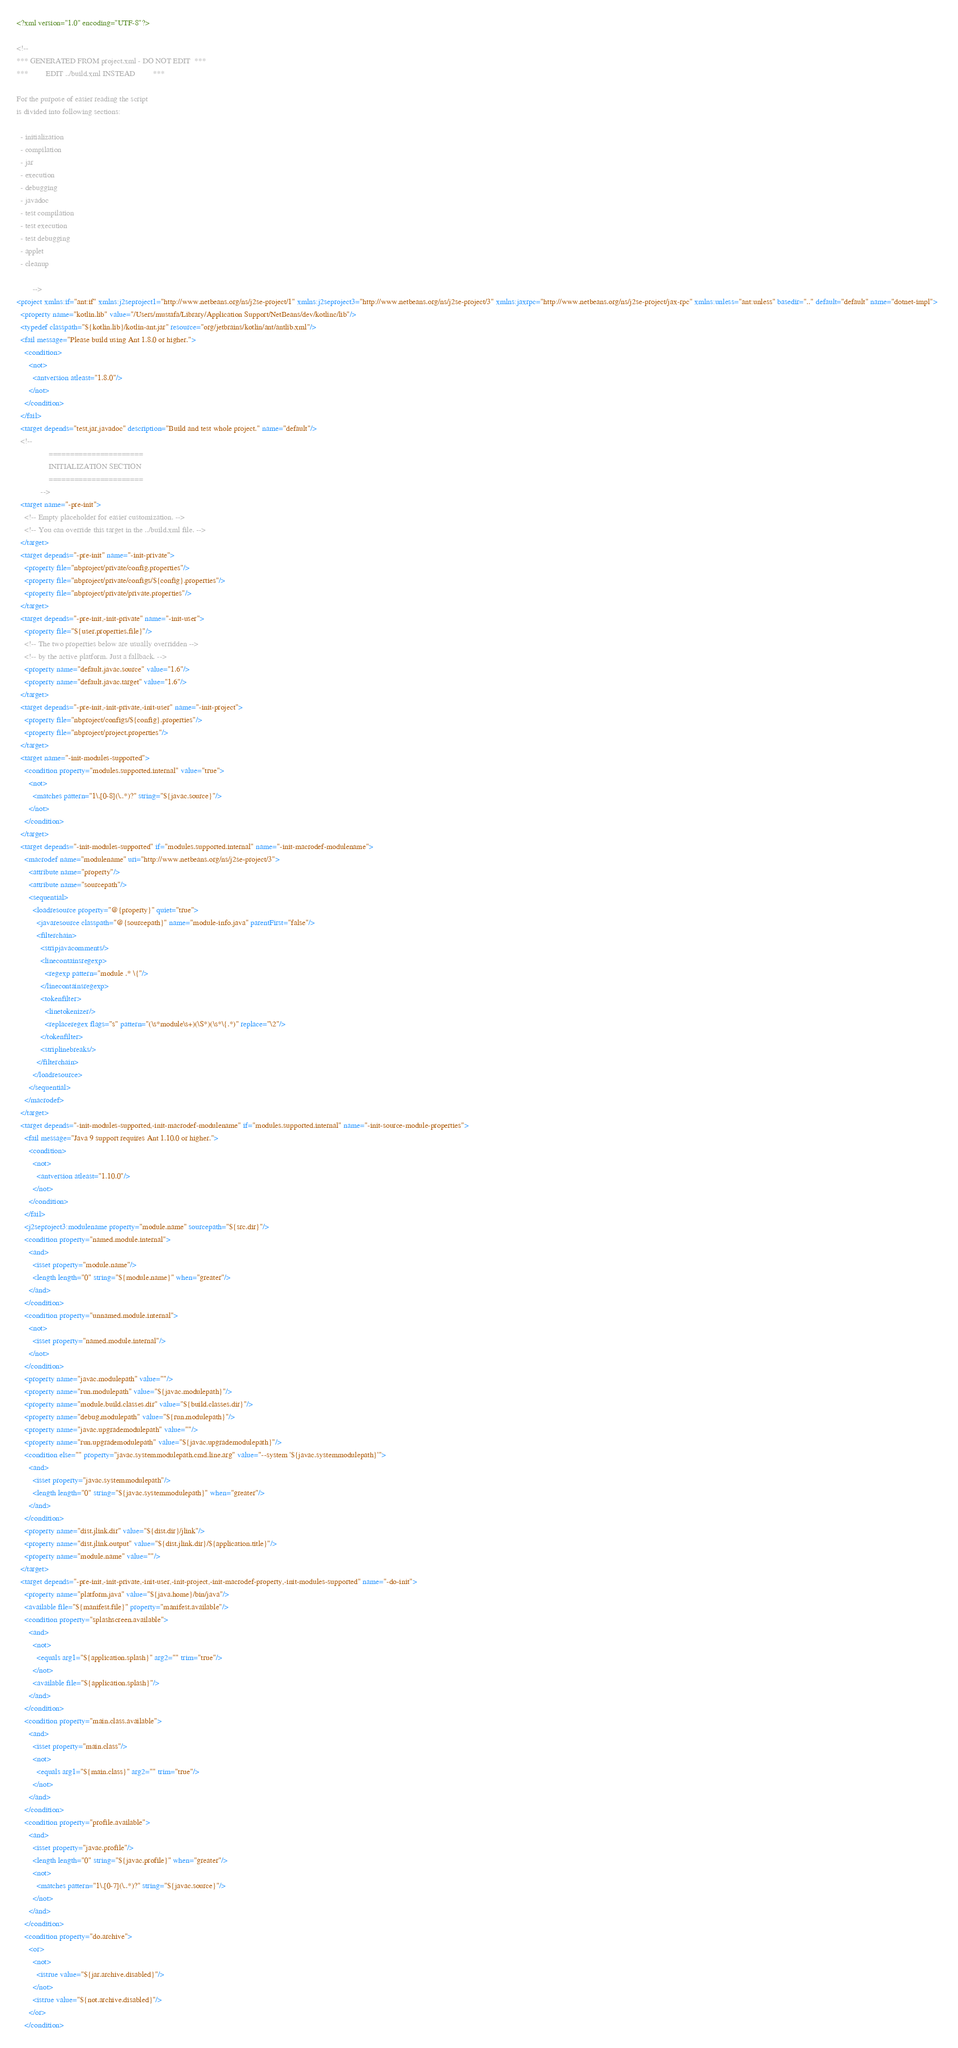Convert code to text. <code><loc_0><loc_0><loc_500><loc_500><_XML_><?xml version="1.0" encoding="UTF-8"?>

<!--
*** GENERATED FROM project.xml - DO NOT EDIT  ***
***         EDIT ../build.xml INSTEAD         ***

For the purpose of easier reading the script
is divided into following sections:

  - initialization
  - compilation
  - jar
  - execution
  - debugging
  - javadoc
  - test compilation
  - test execution
  - test debugging
  - applet
  - cleanup

        -->
<project xmlns:if="ant:if" xmlns:j2seproject1="http://www.netbeans.org/ns/j2se-project/1" xmlns:j2seproject3="http://www.netbeans.org/ns/j2se-project/3" xmlns:jaxrpc="http://www.netbeans.org/ns/j2se-project/jax-rpc" xmlns:unless="ant:unless" basedir=".." default="default" name="dotnet-impl">  
  <property name="kotlin.lib" value="/Users/mustafa/Library/Application Support/NetBeans/dev/kotlinc/lib"/>  
  <typedef classpath="${kotlin.lib}/kotlin-ant.jar" resource="org/jetbrains/kotlin/ant/antlib.xml"/>  
  <fail message="Please build using Ant 1.8.0 or higher."> 
    <condition> 
      <not> 
        <antversion atleast="1.8.0"/> 
      </not> 
    </condition> 
  </fail>  
  <target depends="test,jar,javadoc" description="Build and test whole project." name="default"/>  
  <!-- 
                ======================
                INITIALIZATION SECTION 
                ======================
            -->  
  <target name="-pre-init"> 
    <!-- Empty placeholder for easier customization. -->  
    <!-- You can override this target in the ../build.xml file. --> 
  </target>  
  <target depends="-pre-init" name="-init-private"> 
    <property file="nbproject/private/config.properties"/>  
    <property file="nbproject/private/configs/${config}.properties"/>  
    <property file="nbproject/private/private.properties"/> 
  </target>  
  <target depends="-pre-init,-init-private" name="-init-user"> 
    <property file="${user.properties.file}"/>  
    <!-- The two properties below are usually overridden -->  
    <!-- by the active platform. Just a fallback. -->  
    <property name="default.javac.source" value="1.6"/>  
    <property name="default.javac.target" value="1.6"/> 
  </target>  
  <target depends="-pre-init,-init-private,-init-user" name="-init-project"> 
    <property file="nbproject/configs/${config}.properties"/>  
    <property file="nbproject/project.properties"/> 
  </target>  
  <target name="-init-modules-supported"> 
    <condition property="modules.supported.internal" value="true"> 
      <not> 
        <matches pattern="1\.[0-8](\..*)?" string="${javac.source}"/> 
      </not> 
    </condition> 
  </target>  
  <target depends="-init-modules-supported" if="modules.supported.internal" name="-init-macrodef-modulename"> 
    <macrodef name="modulename" uri="http://www.netbeans.org/ns/j2se-project/3"> 
      <attribute name="property"/>  
      <attribute name="sourcepath"/>  
      <sequential> 
        <loadresource property="@{property}" quiet="true"> 
          <javaresource classpath="@{sourcepath}" name="module-info.java" parentFirst="false"/>  
          <filterchain> 
            <stripjavacomments/>  
            <linecontainsregexp> 
              <regexp pattern="module .* \{"/> 
            </linecontainsregexp>  
            <tokenfilter> 
              <linetokenizer/>  
              <replaceregex flags="s" pattern="(\s*module\s+)(\S*)(\s*\{.*)" replace="\2"/> 
            </tokenfilter>  
            <striplinebreaks/> 
          </filterchain> 
        </loadresource> 
      </sequential> 
    </macrodef> 
  </target>  
  <target depends="-init-modules-supported,-init-macrodef-modulename" if="modules.supported.internal" name="-init-source-module-properties"> 
    <fail message="Java 9 support requires Ant 1.10.0 or higher."> 
      <condition> 
        <not> 
          <antversion atleast="1.10.0"/> 
        </not> 
      </condition> 
    </fail>  
    <j2seproject3:modulename property="module.name" sourcepath="${src.dir}"/>  
    <condition property="named.module.internal"> 
      <and> 
        <isset property="module.name"/>  
        <length length="0" string="${module.name}" when="greater"/> 
      </and> 
    </condition>  
    <condition property="unnamed.module.internal"> 
      <not> 
        <isset property="named.module.internal"/> 
      </not> 
    </condition>  
    <property name="javac.modulepath" value=""/>  
    <property name="run.modulepath" value="${javac.modulepath}"/>  
    <property name="module.build.classes.dir" value="${build.classes.dir}"/>  
    <property name="debug.modulepath" value="${run.modulepath}"/>  
    <property name="javac.upgrademodulepath" value=""/>  
    <property name="run.upgrademodulepath" value="${javac.upgrademodulepath}"/>  
    <condition else="" property="javac.systemmodulepath.cmd.line.arg" value="--system '${javac.systemmodulepath}'"> 
      <and> 
        <isset property="javac.systemmodulepath"/>  
        <length length="0" string="${javac.systemmodulepath}" when="greater"/> 
      </and> 
    </condition>  
    <property name="dist.jlink.dir" value="${dist.dir}/jlink"/>  
    <property name="dist.jlink.output" value="${dist.jlink.dir}/${application.title}"/>  
    <property name="module.name" value=""/> 
  </target>  
  <target depends="-pre-init,-init-private,-init-user,-init-project,-init-macrodef-property,-init-modules-supported" name="-do-init"> 
    <property name="platform.java" value="${java.home}/bin/java"/>  
    <available file="${manifest.file}" property="manifest.available"/>  
    <condition property="splashscreen.available"> 
      <and> 
        <not> 
          <equals arg1="${application.splash}" arg2="" trim="true"/> 
        </not>  
        <available file="${application.splash}"/> 
      </and> 
    </condition>  
    <condition property="main.class.available"> 
      <and> 
        <isset property="main.class"/>  
        <not> 
          <equals arg1="${main.class}" arg2="" trim="true"/> 
        </not> 
      </and> 
    </condition>  
    <condition property="profile.available"> 
      <and> 
        <isset property="javac.profile"/>  
        <length length="0" string="${javac.profile}" when="greater"/>  
        <not> 
          <matches pattern="1\.[0-7](\..*)?" string="${javac.source}"/> 
        </not> 
      </and> 
    </condition>  
    <condition property="do.archive"> 
      <or> 
        <not> 
          <istrue value="${jar.archive.disabled}"/> 
        </not>  
        <istrue value="${not.archive.disabled}"/> 
      </or> 
    </condition>  </code> 